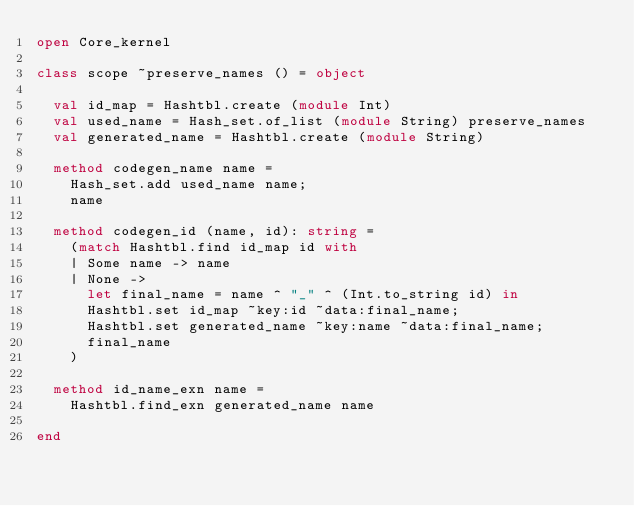Convert code to text. <code><loc_0><loc_0><loc_500><loc_500><_OCaml_>open Core_kernel

class scope ~preserve_names () = object

  val id_map = Hashtbl.create (module Int)
  val used_name = Hash_set.of_list (module String) preserve_names
  val generated_name = Hashtbl.create (module String)

  method codegen_name name =
    Hash_set.add used_name name;
    name
  
  method codegen_id (name, id): string =
    (match Hashtbl.find id_map id with
    | Some name -> name
    | None ->
      let final_name = name ^ "_" ^ (Int.to_string id) in
      Hashtbl.set id_map ~key:id ~data:final_name;
      Hashtbl.set generated_name ~key:name ~data:final_name;
      final_name
    )

  method id_name_exn name =
    Hashtbl.find_exn generated_name name
  
end
</code> 